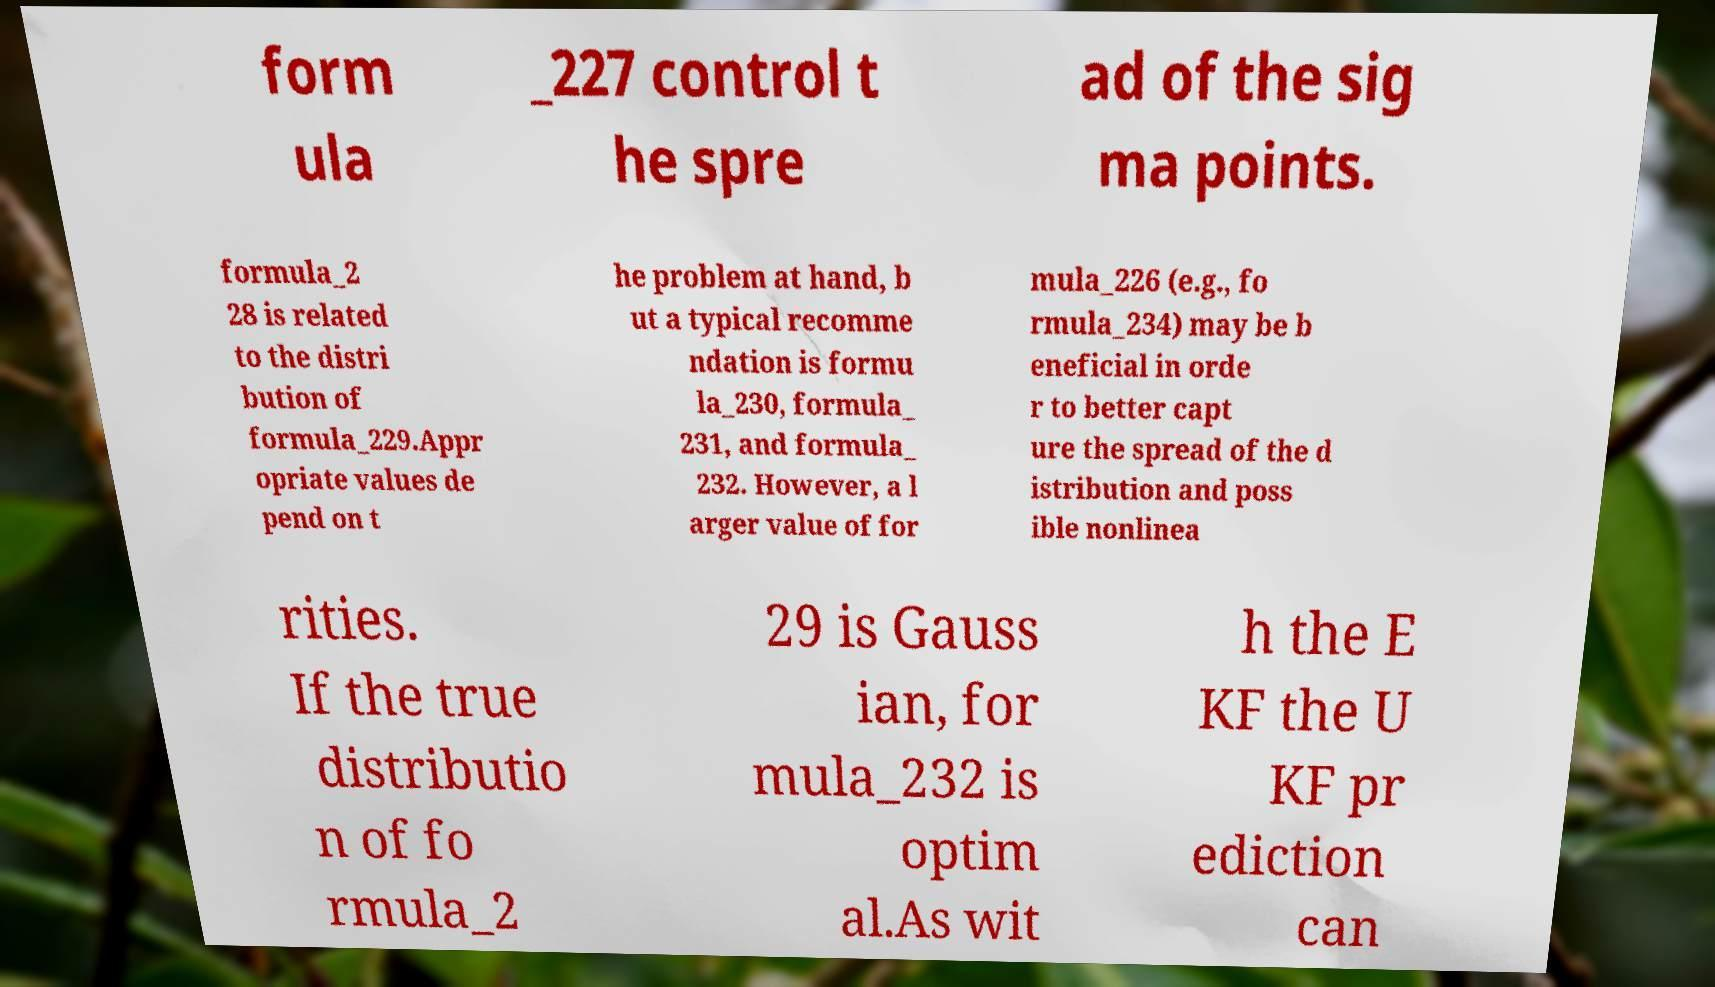There's text embedded in this image that I need extracted. Can you transcribe it verbatim? form ula _227 control t he spre ad of the sig ma points. formula_2 28 is related to the distri bution of formula_229.Appr opriate values de pend on t he problem at hand, b ut a typical recomme ndation is formu la_230, formula_ 231, and formula_ 232. However, a l arger value of for mula_226 (e.g., fo rmula_234) may be b eneficial in orde r to better capt ure the spread of the d istribution and poss ible nonlinea rities. If the true distributio n of fo rmula_2 29 is Gauss ian, for mula_232 is optim al.As wit h the E KF the U KF pr ediction can 